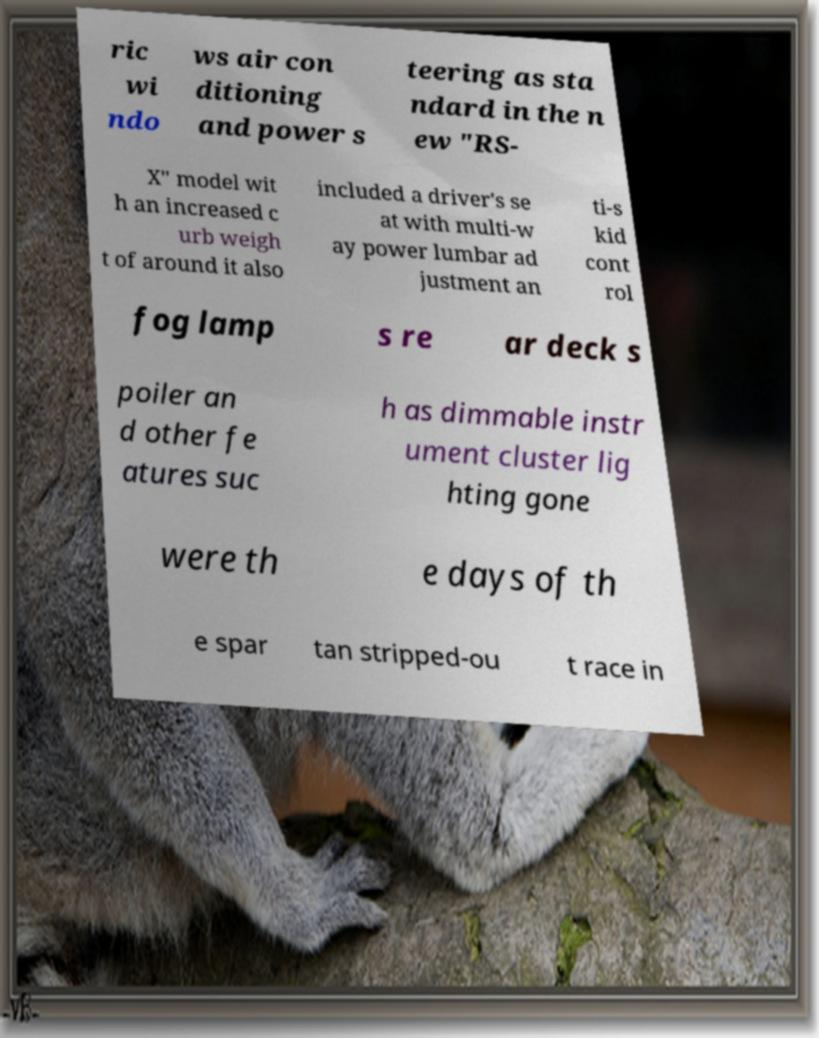Could you extract and type out the text from this image? ric wi ndo ws air con ditioning and power s teering as sta ndard in the n ew "RS- X" model wit h an increased c urb weigh t of around it also included a driver's se at with multi-w ay power lumbar ad justment an ti-s kid cont rol fog lamp s re ar deck s poiler an d other fe atures suc h as dimmable instr ument cluster lig hting gone were th e days of th e spar tan stripped-ou t race in 